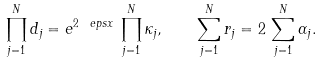Convert formula to latex. <formula><loc_0><loc_0><loc_500><loc_500>\prod _ { j = 1 } ^ { N } d _ { j } = e ^ { 2 \ e p s x } \, \prod _ { j = 1 } ^ { N } \kappa _ { j } , \quad \sum _ { j = 1 } ^ { N } r _ { j } = 2 \, \sum _ { j = 1 } ^ { N } \alpha _ { j } .</formula> 